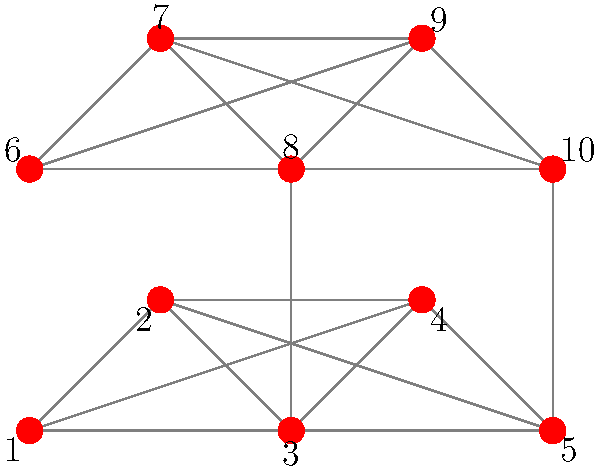Given the social network graph above, which graph clustering algorithm would be most suitable for detecting the two distinct communities, and what is the expected modularity score range for this network structure? To answer this question, let's follow these steps:

1. Analyze the graph structure:
   - The graph shows two distinct clusters of nodes (1-5 and 6-10).
   - There are two weak connections between the clusters (3-8 and 5-10).

2. Choose an appropriate clustering algorithm:
   - For detecting communities in social networks, the Louvain algorithm is highly effective.
   - It's fast, scalable, and works well for detecting communities in large networks.

3. Understanding modularity:
   - Modularity measures the strength of division of a network into communities.
   - It ranges from -1 to 1, where higher values indicate better community structure.

4. Estimating the modularity score:
   - Given the clear separation between the two communities with only two weak inter-community connections, we can expect a high modularity score.
   - Typically, modularity scores above 0.3 are considered good.
   - For this network structure, we can expect a modularity score in the range of 0.7 to 0.9.

5. Justification for the high modularity expectation:
   - Strong intra-community connections
   - Weak inter-community connections
   - Clear visual separation of the two communities

Therefore, the Louvain algorithm would be most suitable for detecting these communities, and we can expect a high modularity score in the range of 0.7 to 0.9.
Answer: Louvain algorithm; 0.7-0.9 modularity 